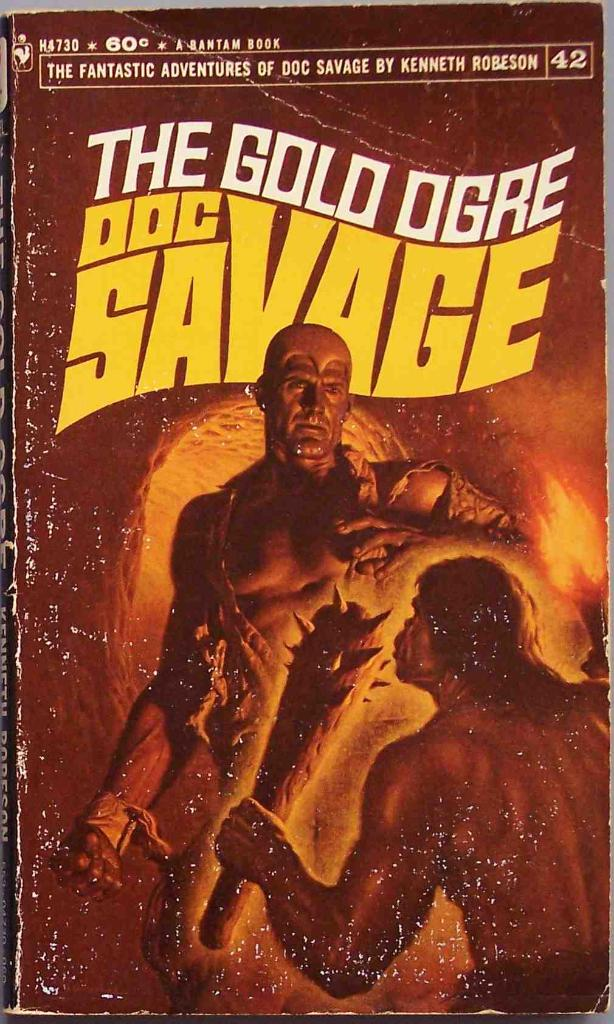What can you infer about the genre of the book and the era it represents based on the cover art? The genre of the book likely leans towards adventure or fantasy, given the depiction of the supernatural creature and heroic confrontation. The art style, with its dramatic and somewhat exaggerated portrayal, along with the typeface used for the title, suggests it belongs to the mid-20th century, a period when pulp fiction was popular. These books often featured vivid, action-packed cover art to attract readers, indicative of the storytelling style that emphasized sensationalism and fast-paced plots. 